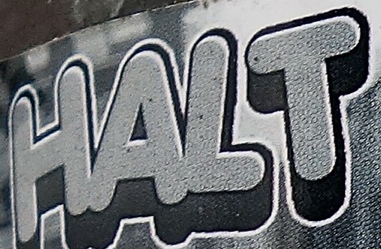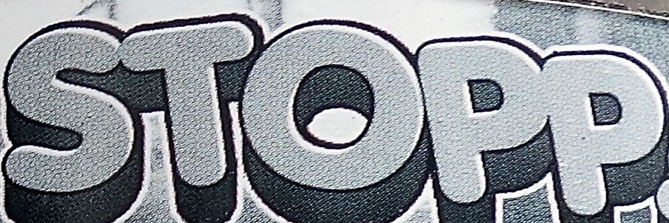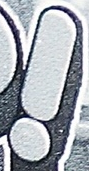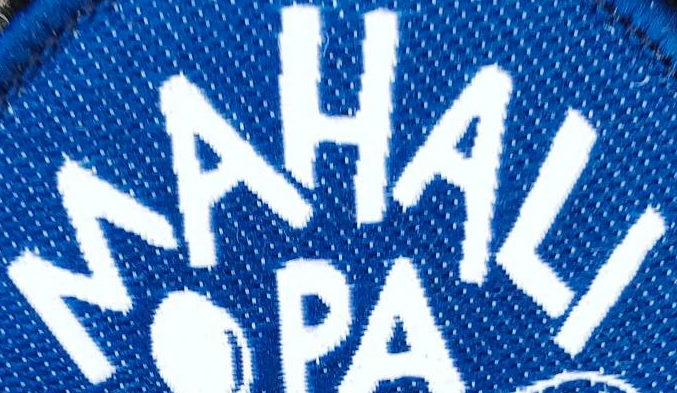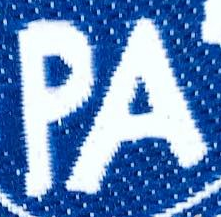Read the text from these images in sequence, separated by a semicolon. HALT; STOPP; !; MAHALI; PA 